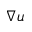<formula> <loc_0><loc_0><loc_500><loc_500>\nabla u</formula> 